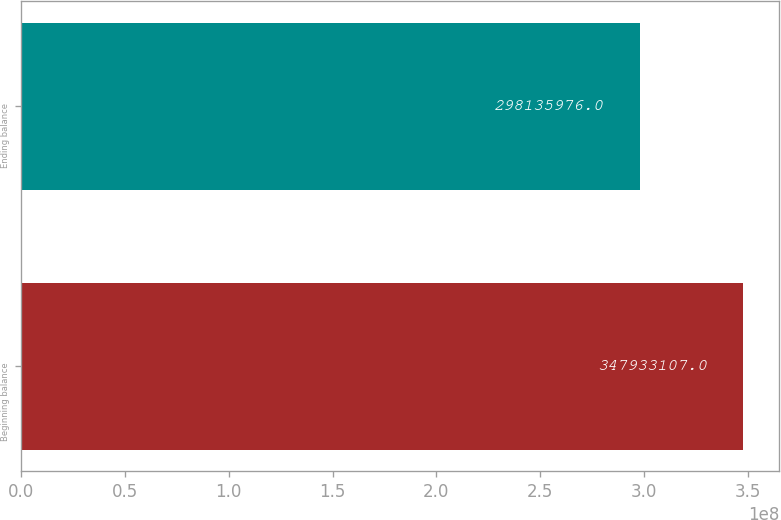<chart> <loc_0><loc_0><loc_500><loc_500><bar_chart><fcel>Beginning balance<fcel>Ending balance<nl><fcel>3.47933e+08<fcel>2.98136e+08<nl></chart> 